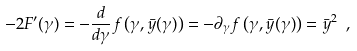<formula> <loc_0><loc_0><loc_500><loc_500>- 2 F ^ { \prime } ( \gamma ) = - \frac { d } { d \gamma } f \left ( \gamma , \bar { y } ( \gamma ) \right ) = - { \partial _ { \gamma } } f \left ( \gamma , \bar { y } ( \gamma ) \right ) = \bar { y } ^ { 2 } \ ,</formula> 